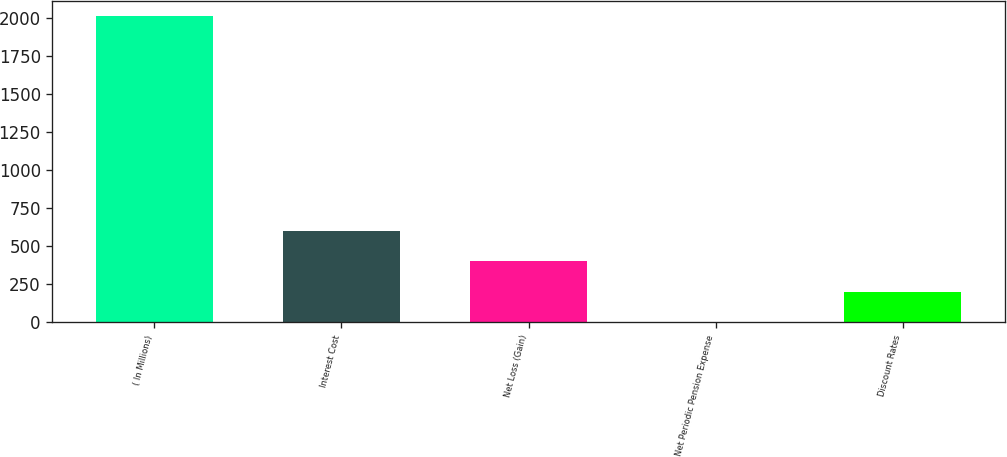Convert chart to OTSL. <chart><loc_0><loc_0><loc_500><loc_500><bar_chart><fcel>( In Millions)<fcel>Interest Cost<fcel>Net Loss (Gain)<fcel>Net Periodic Pension Expense<fcel>Discount Rates<nl><fcel>2014<fcel>604.55<fcel>403.2<fcel>0.5<fcel>201.85<nl></chart> 